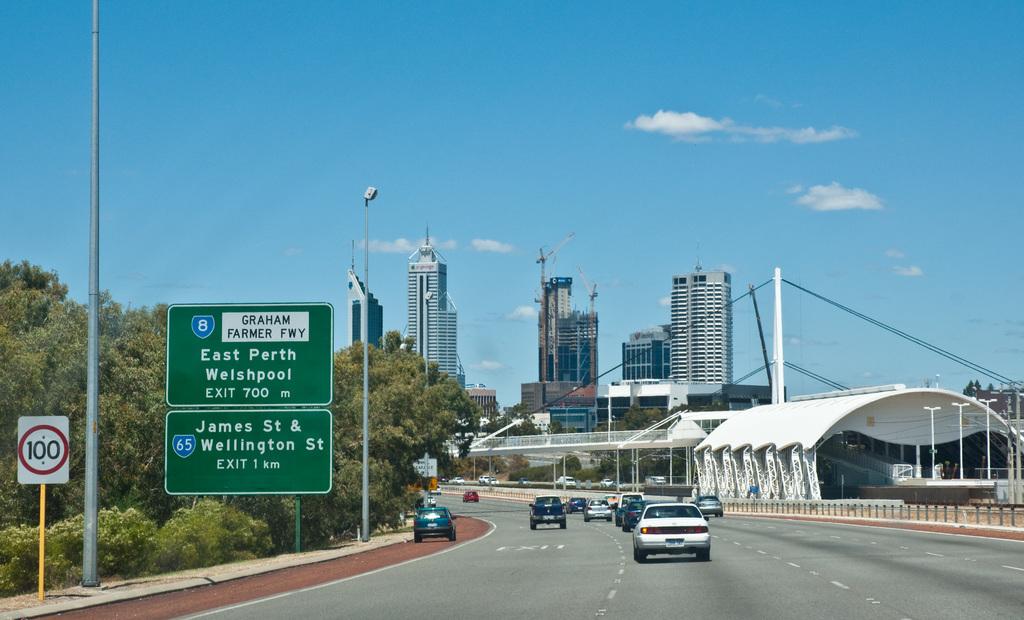What exit number is this?
Make the answer very short. 8. 